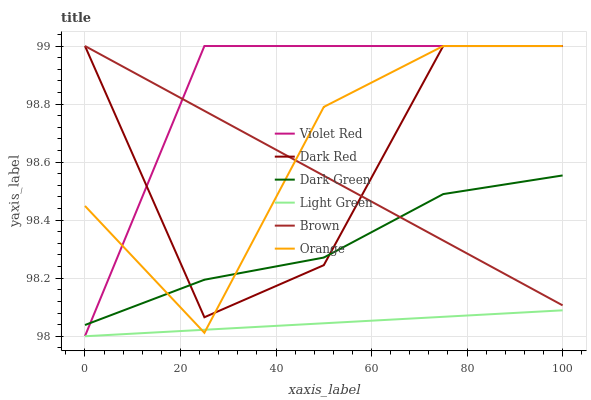Does Dark Red have the minimum area under the curve?
Answer yes or no. No. Does Dark Red have the maximum area under the curve?
Answer yes or no. No. Is Violet Red the smoothest?
Answer yes or no. No. Is Violet Red the roughest?
Answer yes or no. No. Does Violet Red have the lowest value?
Answer yes or no. No. Does Light Green have the highest value?
Answer yes or no. No. Is Light Green less than Brown?
Answer yes or no. Yes. Is Brown greater than Light Green?
Answer yes or no. Yes. Does Light Green intersect Brown?
Answer yes or no. No. 